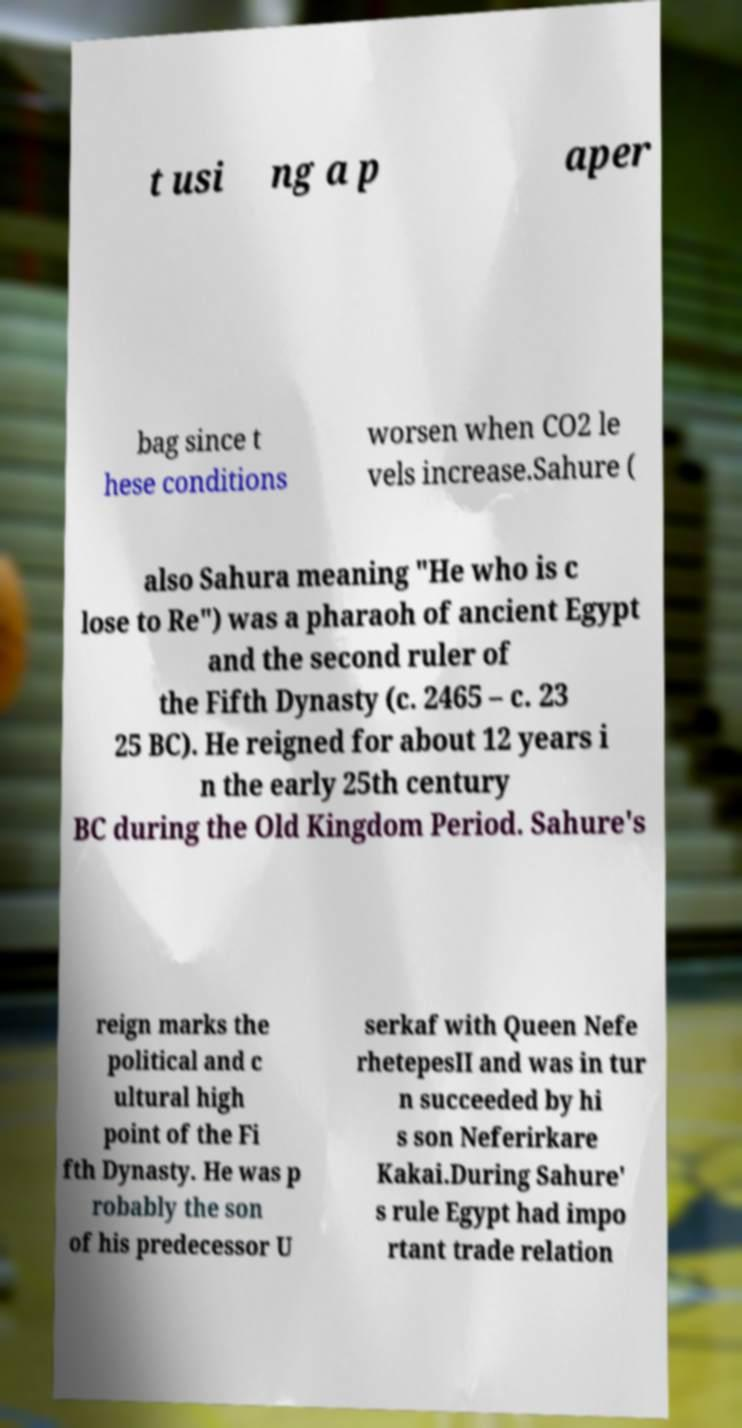Please identify and transcribe the text found in this image. t usi ng a p aper bag since t hese conditions worsen when CO2 le vels increase.Sahure ( also Sahura meaning "He who is c lose to Re") was a pharaoh of ancient Egypt and the second ruler of the Fifth Dynasty (c. 2465 – c. 23 25 BC). He reigned for about 12 years i n the early 25th century BC during the Old Kingdom Period. Sahure's reign marks the political and c ultural high point of the Fi fth Dynasty. He was p robably the son of his predecessor U serkaf with Queen Nefe rhetepesII and was in tur n succeeded by hi s son Neferirkare Kakai.During Sahure' s rule Egypt had impo rtant trade relation 